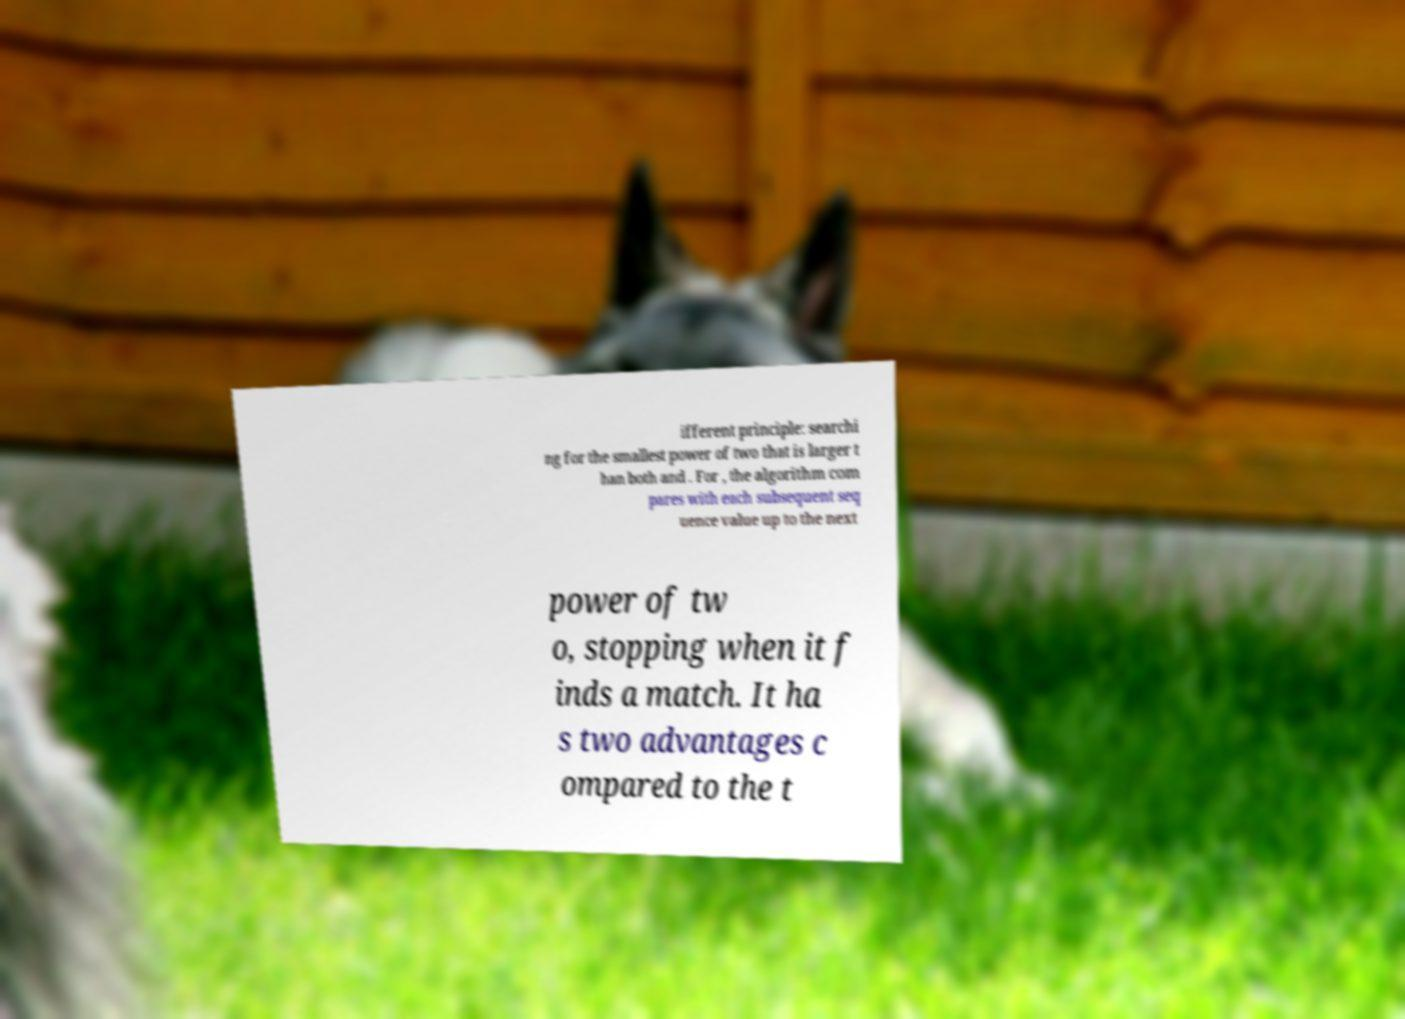Please identify and transcribe the text found in this image. ifferent principle: searchi ng for the smallest power of two that is larger t han both and . For , the algorithm com pares with each subsequent seq uence value up to the next power of tw o, stopping when it f inds a match. It ha s two advantages c ompared to the t 